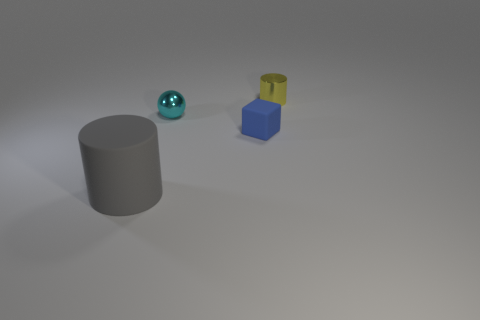There is a metal object that is in front of the tiny yellow cylinder; what number of small blue blocks are left of it? Observing the objects in the image, there are no small blue blocks situated to the left of the shiny metal sphere when facing the yellow cylinder. The area to the left is clear of any blue objects or blocks. 